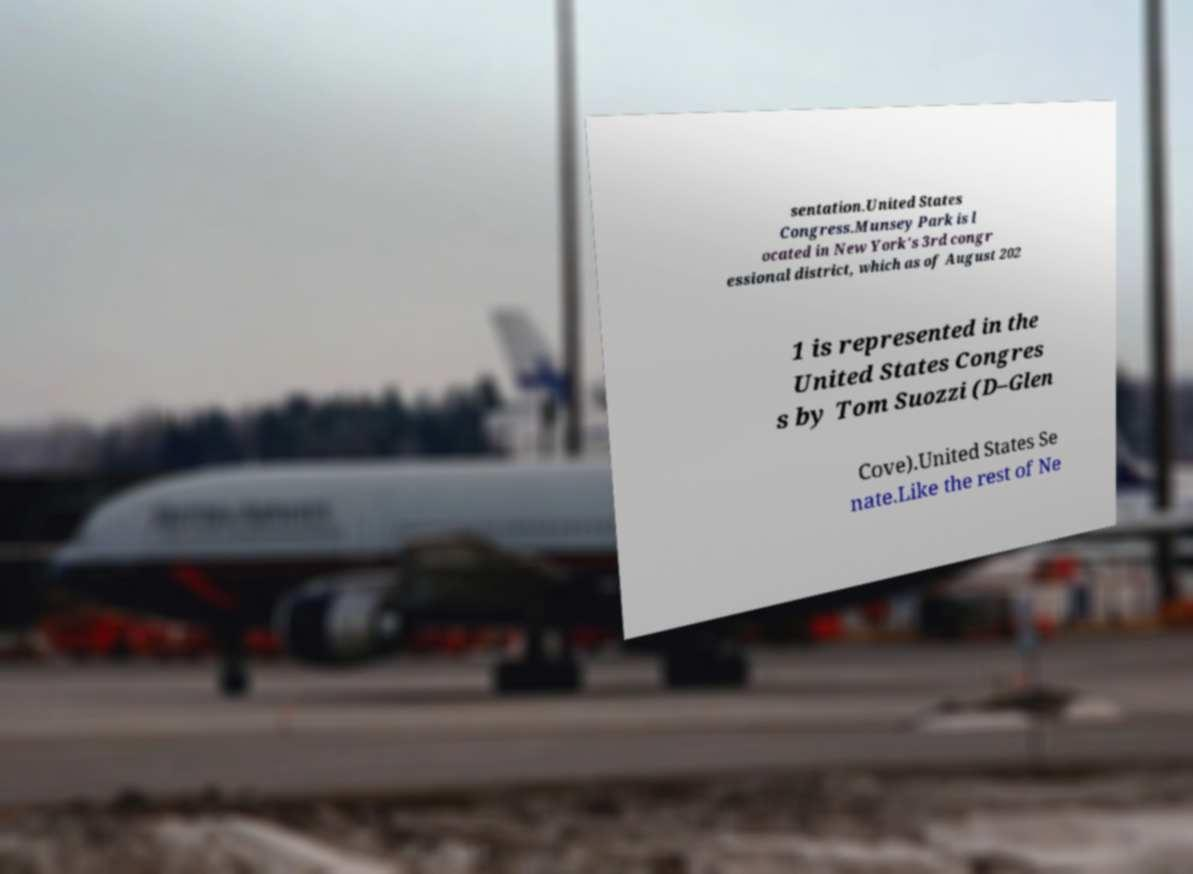There's text embedded in this image that I need extracted. Can you transcribe it verbatim? sentation.United States Congress.Munsey Park is l ocated in New York's 3rd congr essional district, which as of August 202 1 is represented in the United States Congres s by Tom Suozzi (D–Glen Cove).United States Se nate.Like the rest of Ne 